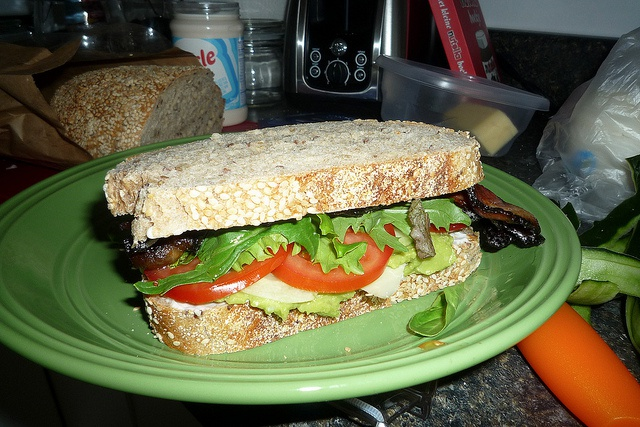Describe the objects in this image and their specific colors. I can see sandwich in black, khaki, beige, and olive tones, bowl in black, gray, and darkgreen tones, carrot in black, red, and brown tones, and book in black, maroon, gray, and brown tones in this image. 